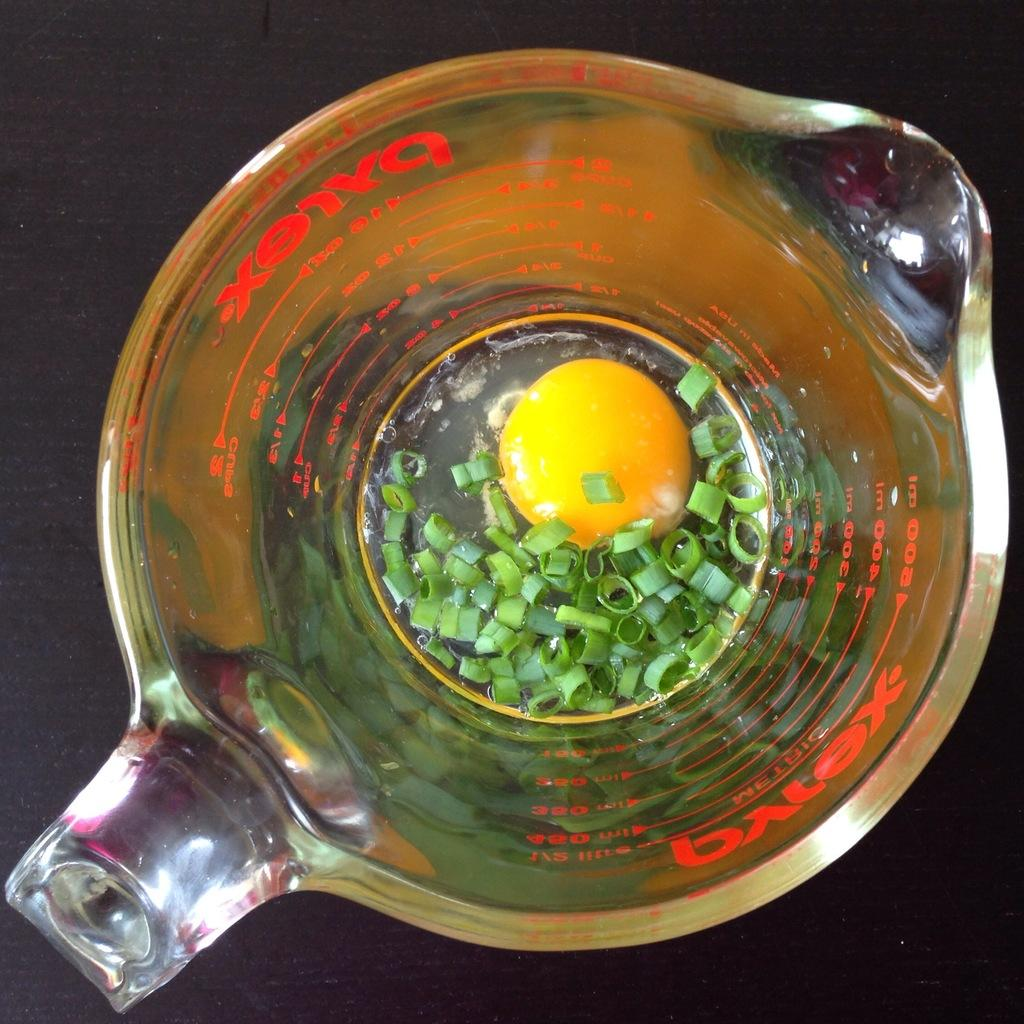<image>
Share a concise interpretation of the image provided. A glass Pyrex measuring cup which contains chopped green onions and an egg yolk. 